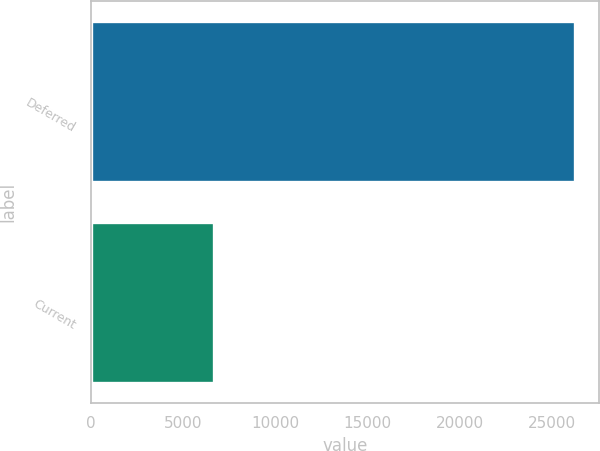<chart> <loc_0><loc_0><loc_500><loc_500><bar_chart><fcel>Deferred<fcel>Current<nl><fcel>26240<fcel>6664<nl></chart> 